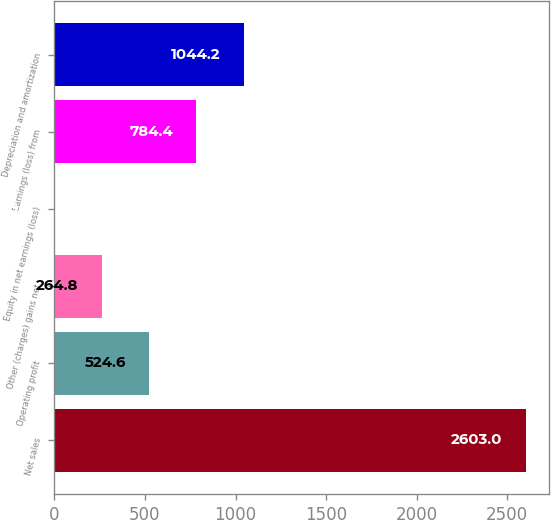<chart> <loc_0><loc_0><loc_500><loc_500><bar_chart><fcel>Net sales<fcel>Operating profit<fcel>Other (charges) gains net<fcel>Equity in net earnings (loss)<fcel>Earnings (loss) from<fcel>Depreciation and amortization<nl><fcel>2603<fcel>524.6<fcel>264.8<fcel>5<fcel>784.4<fcel>1044.2<nl></chart> 